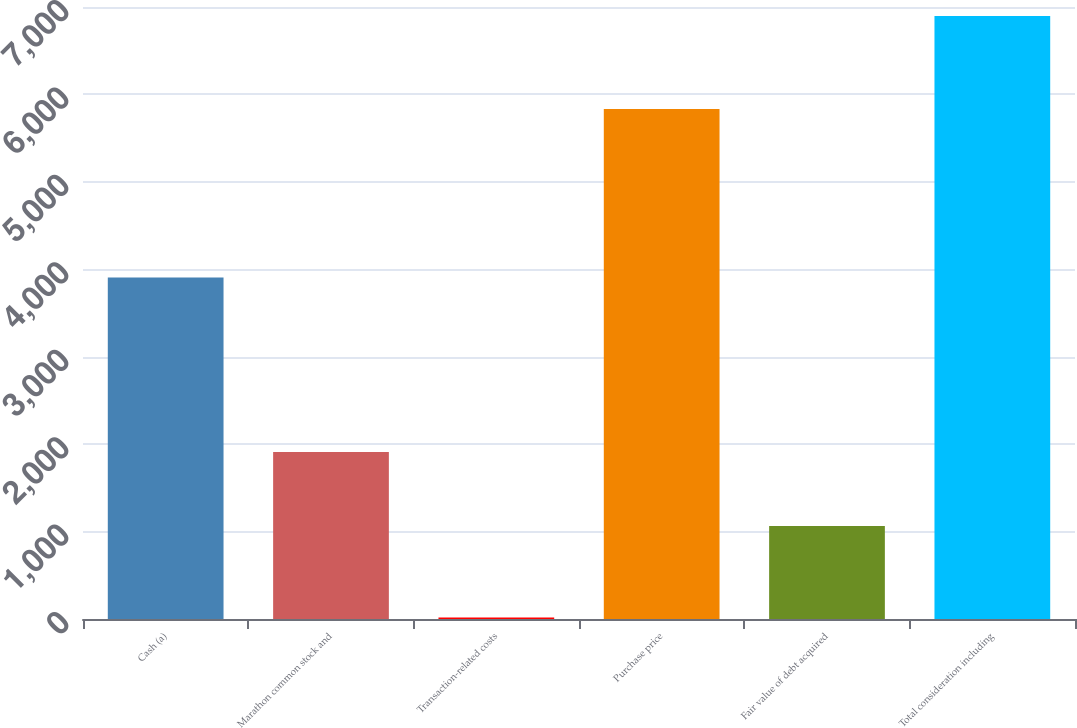Convert chart. <chart><loc_0><loc_0><loc_500><loc_500><bar_chart><fcel>Cash (a)<fcel>Marathon common stock and<fcel>Transaction-related costs<fcel>Purchase price<fcel>Fair value of debt acquired<fcel>Total consideration including<nl><fcel>3907<fcel>1910<fcel>16<fcel>5833<fcel>1063<fcel>6896<nl></chart> 